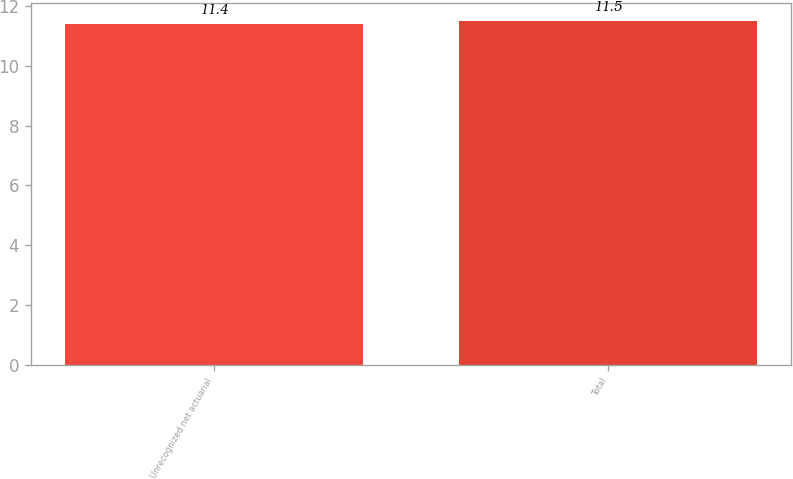<chart> <loc_0><loc_0><loc_500><loc_500><bar_chart><fcel>Unrecognized net actuarial<fcel>Total<nl><fcel>11.4<fcel>11.5<nl></chart> 